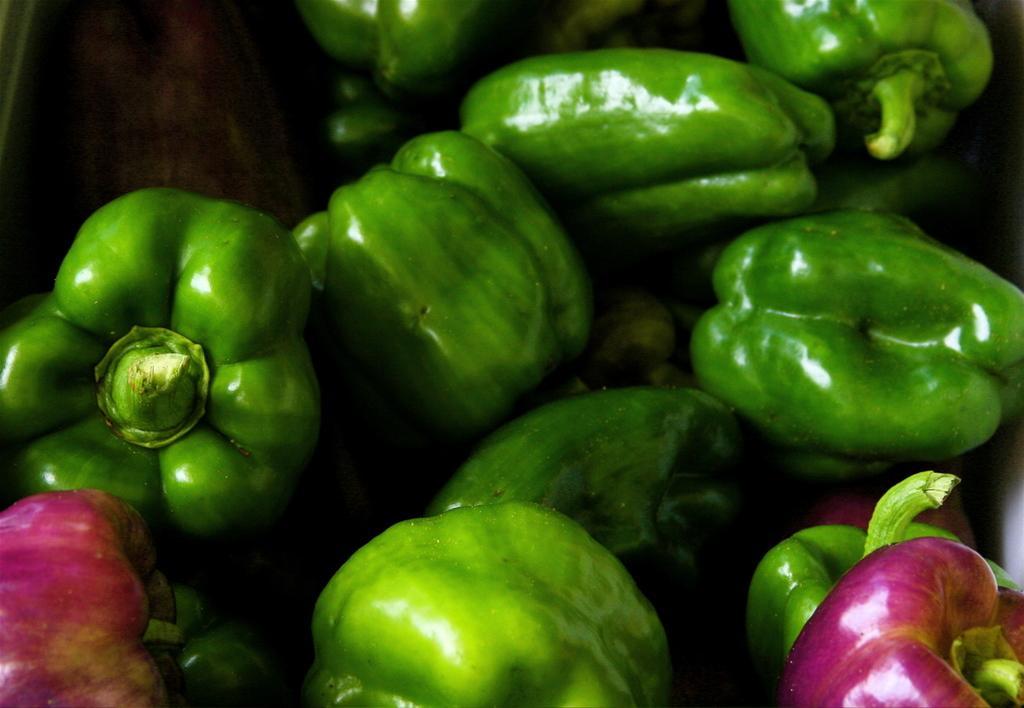Can you describe this image briefly? In the center of the image there are vegetables. 